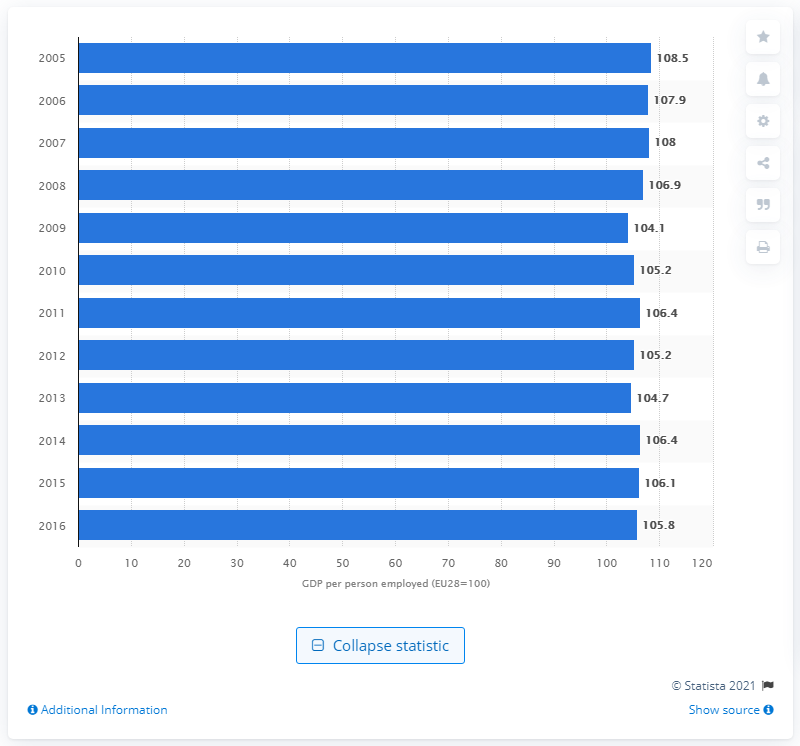Specify some key components in this picture. The peak of labor productivity in 2005 was 108.5. 